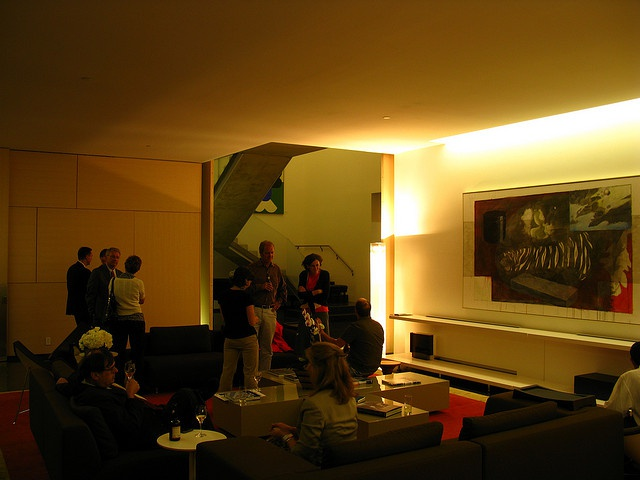Describe the objects in this image and their specific colors. I can see couch in black and maroon tones, couch in black, maroon, and brown tones, people in black, maroon, and olive tones, dining table in black, maroon, and olive tones, and people in black, maroon, and olive tones in this image. 